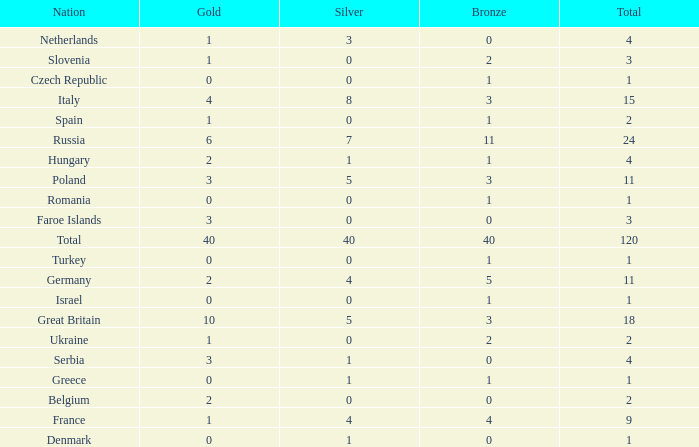What is the average Gold entry for the Netherlands that also has a Bronze entry that is greater than 0? None. 